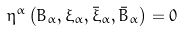<formula> <loc_0><loc_0><loc_500><loc_500>\eta ^ { \alpha } \left ( B _ { \alpha } , \xi _ { \alpha } , \bar { \xi } _ { \alpha } , \bar { B } _ { \alpha } \right ) = 0</formula> 